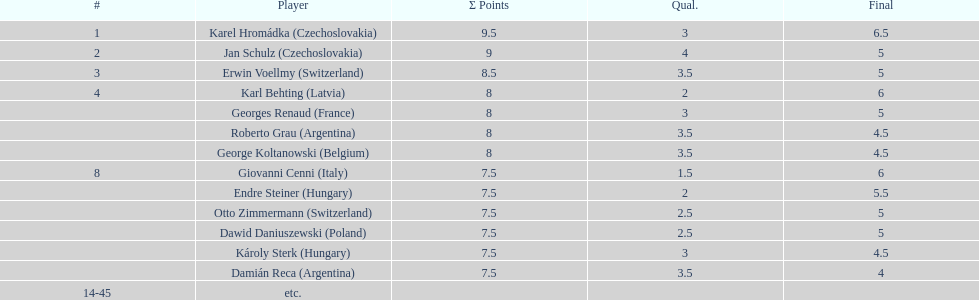Who was the top scorer from switzerland? Erwin Voellmy. 